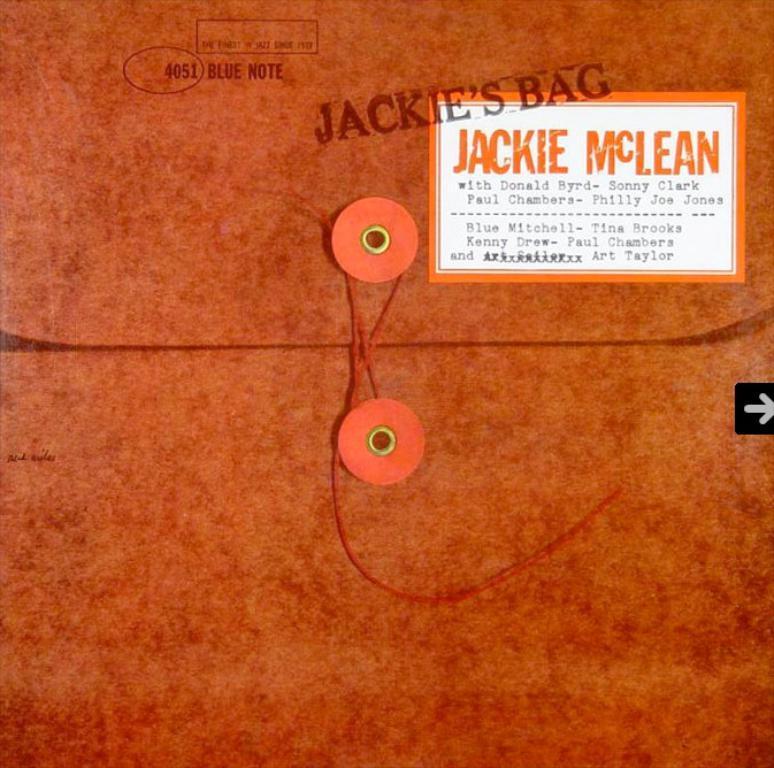Please provide a concise description of this image. In this image, we can see a poster with some objects and threads. We can also see a label with some text. We can see the stamp. 